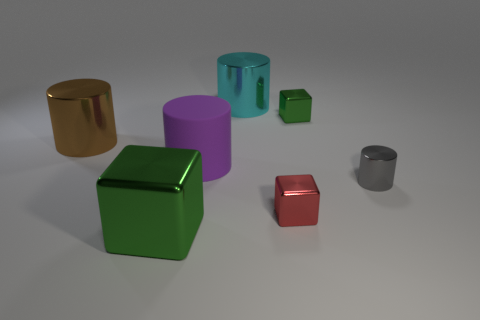Is the number of large purple objects that are behind the red metallic cube greater than the number of shiny cylinders left of the brown metallic cylinder? Actually, there are no large purple objects directly behind the red metallic cube; there is only one large purple cylinder in the scene, and it is not positioned behind the red cube. There is also only one shiny cylinder, which appears to be silver and is located to the left of the brown metallic cylinder. With this in mind, the answer is no, the number of large purple objects behind the red metallic cube is not greater than the number of shiny cylinders left of the brown metallic cylinder, as both the numbers we're comparing are zero. 